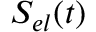Convert formula to latex. <formula><loc_0><loc_0><loc_500><loc_500>S _ { e l } ( t )</formula> 